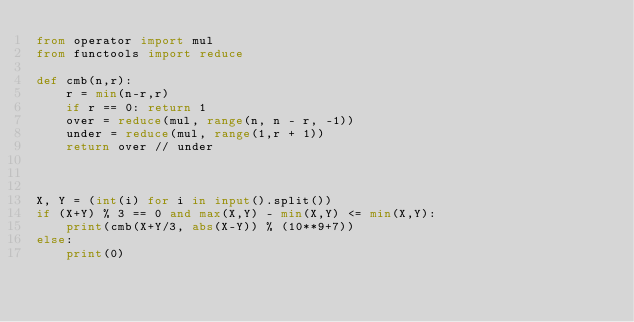<code> <loc_0><loc_0><loc_500><loc_500><_Python_>from operator import mul
from functools import reduce

def cmb(n,r):
    r = min(n-r,r)
    if r == 0: return 1
    over = reduce(mul, range(n, n - r, -1))
    under = reduce(mul, range(1,r + 1))
    return over // under



X, Y = (int(i) for i in input().split())
if (X+Y) % 3 == 0 and max(X,Y) - min(X,Y) <= min(X,Y):
    print(cmb(X+Y/3, abs(X-Y)) % (10**9+7))
else:
    print(0)</code> 